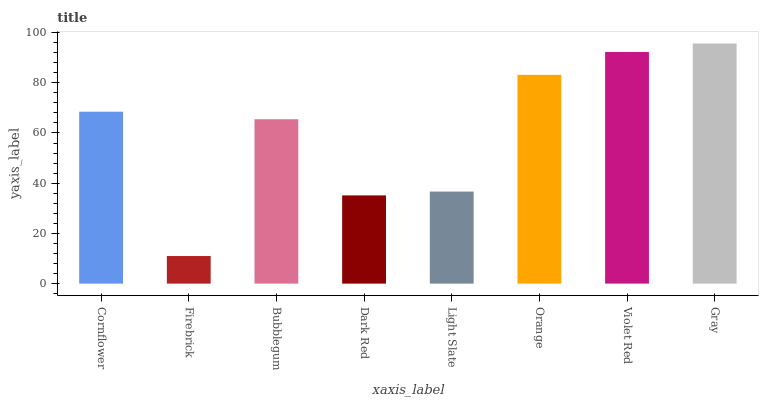Is Firebrick the minimum?
Answer yes or no. Yes. Is Gray the maximum?
Answer yes or no. Yes. Is Bubblegum the minimum?
Answer yes or no. No. Is Bubblegum the maximum?
Answer yes or no. No. Is Bubblegum greater than Firebrick?
Answer yes or no. Yes. Is Firebrick less than Bubblegum?
Answer yes or no. Yes. Is Firebrick greater than Bubblegum?
Answer yes or no. No. Is Bubblegum less than Firebrick?
Answer yes or no. No. Is Cornflower the high median?
Answer yes or no. Yes. Is Bubblegum the low median?
Answer yes or no. Yes. Is Firebrick the high median?
Answer yes or no. No. Is Dark Red the low median?
Answer yes or no. No. 